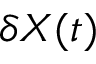<formula> <loc_0><loc_0><loc_500><loc_500>\delta X ( t )</formula> 